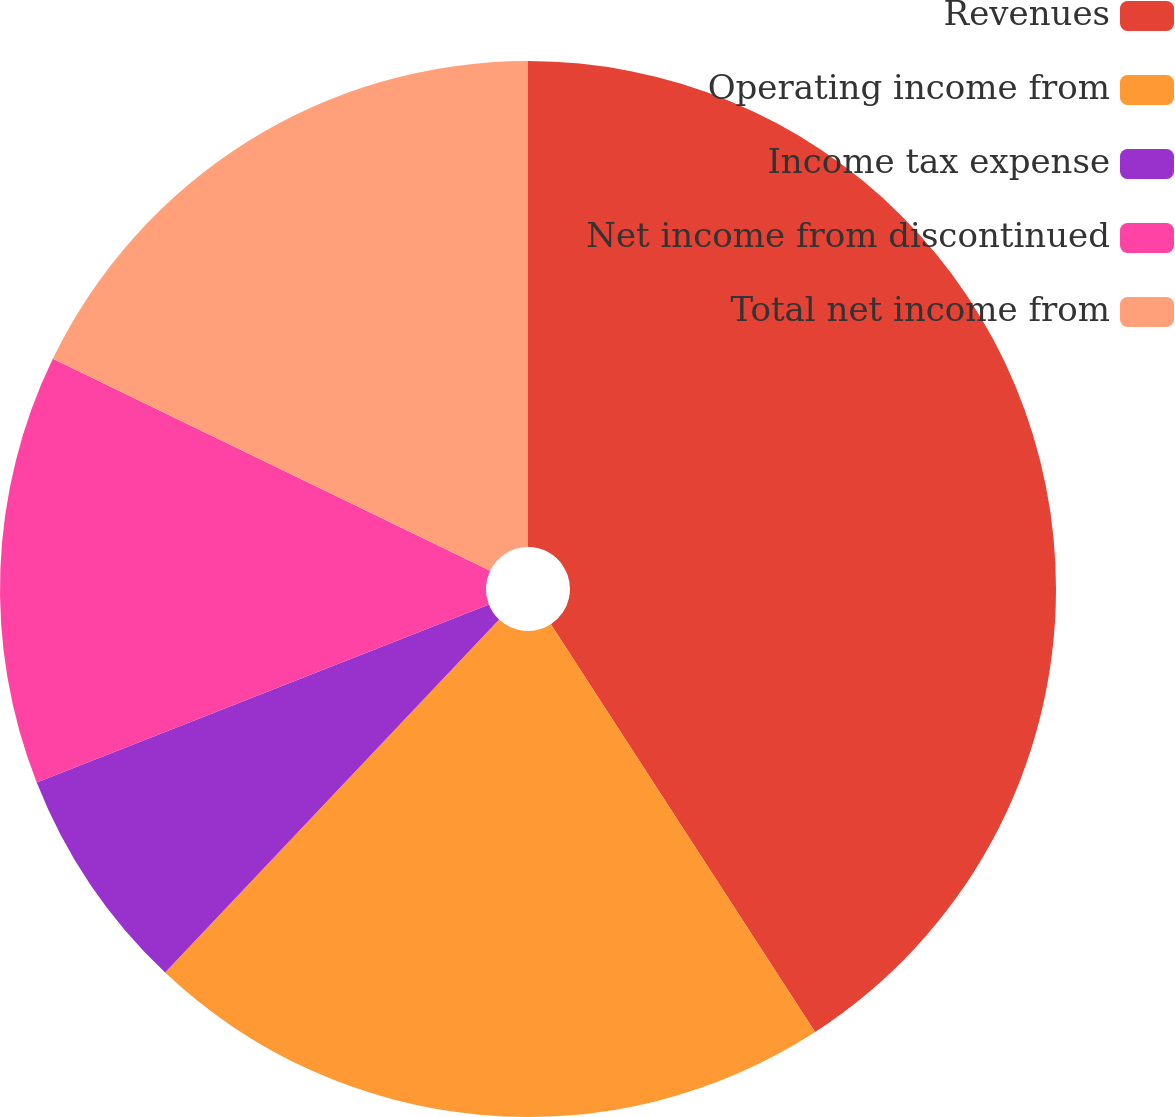<chart> <loc_0><loc_0><loc_500><loc_500><pie_chart><fcel>Revenues<fcel>Operating income from<fcel>Income tax expense<fcel>Net income from discontinued<fcel>Total net income from<nl><fcel>40.85%<fcel>21.21%<fcel>6.97%<fcel>13.15%<fcel>17.82%<nl></chart> 